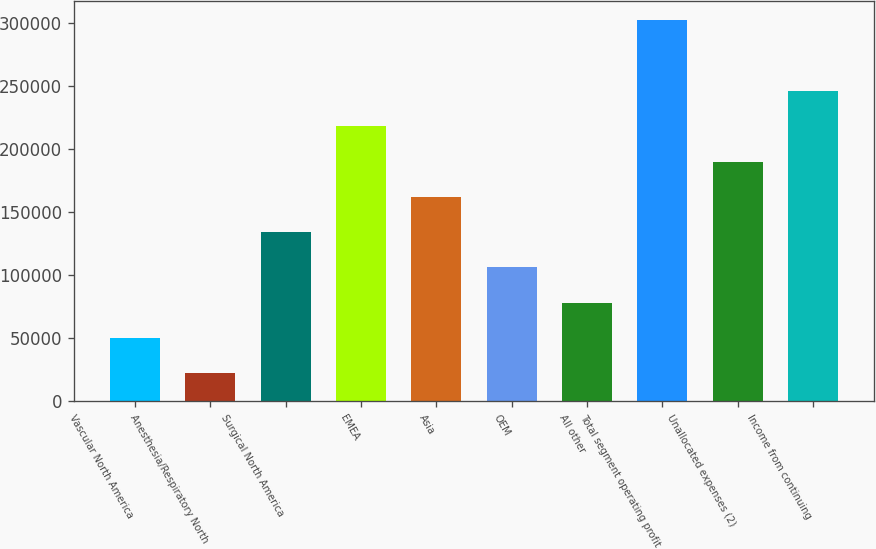Convert chart. <chart><loc_0><loc_0><loc_500><loc_500><bar_chart><fcel>Vascular North America<fcel>Anesthesia/Respiratory North<fcel>Surgical North America<fcel>EMEA<fcel>Asia<fcel>OEM<fcel>All other<fcel>Total segment operating profit<fcel>Unallocated expenses (2)<fcel>Income from continuing<nl><fcel>49947.5<fcel>21910<fcel>134060<fcel>218172<fcel>162098<fcel>106022<fcel>77985<fcel>302285<fcel>190135<fcel>246210<nl></chart> 